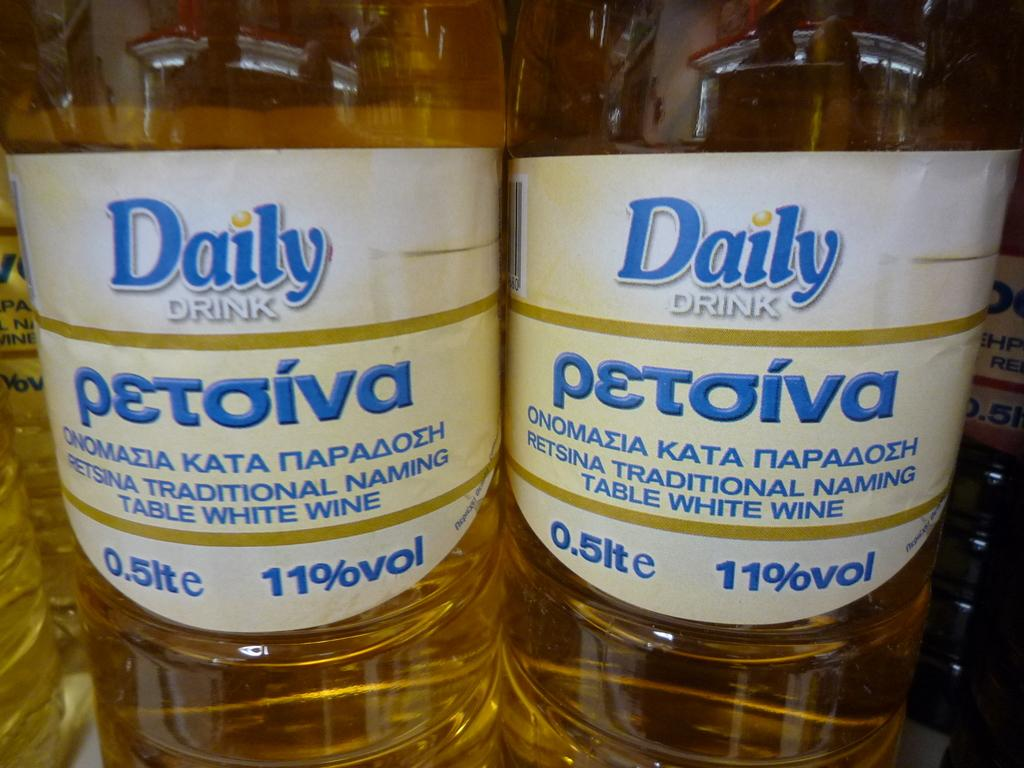<image>
Relay a brief, clear account of the picture shown. Daily Drink Petoiva that is 11% by volume and 0.5 liters. 